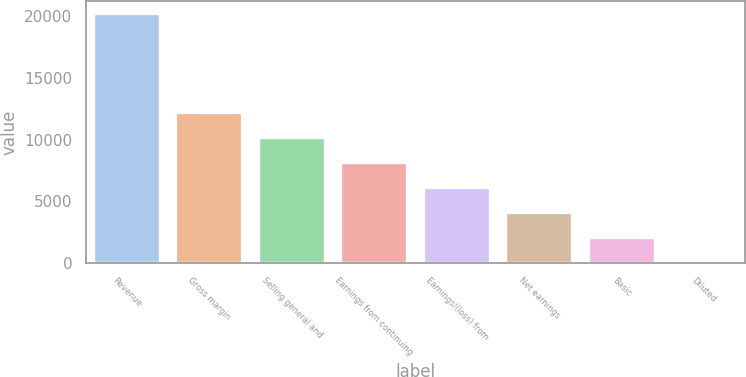Convert chart to OTSL. <chart><loc_0><loc_0><loc_500><loc_500><bar_chart><fcel>Revenue<fcel>Gross margin<fcel>Selling general and<fcel>Earnings from continuing<fcel>Earnings/(loss) from<fcel>Net earnings<fcel>Basic<fcel>Diluted<nl><fcel>20213.2<fcel>12128.2<fcel>10107<fcel>8085.76<fcel>6064.52<fcel>4043.28<fcel>2022.04<fcel>0.8<nl></chart> 